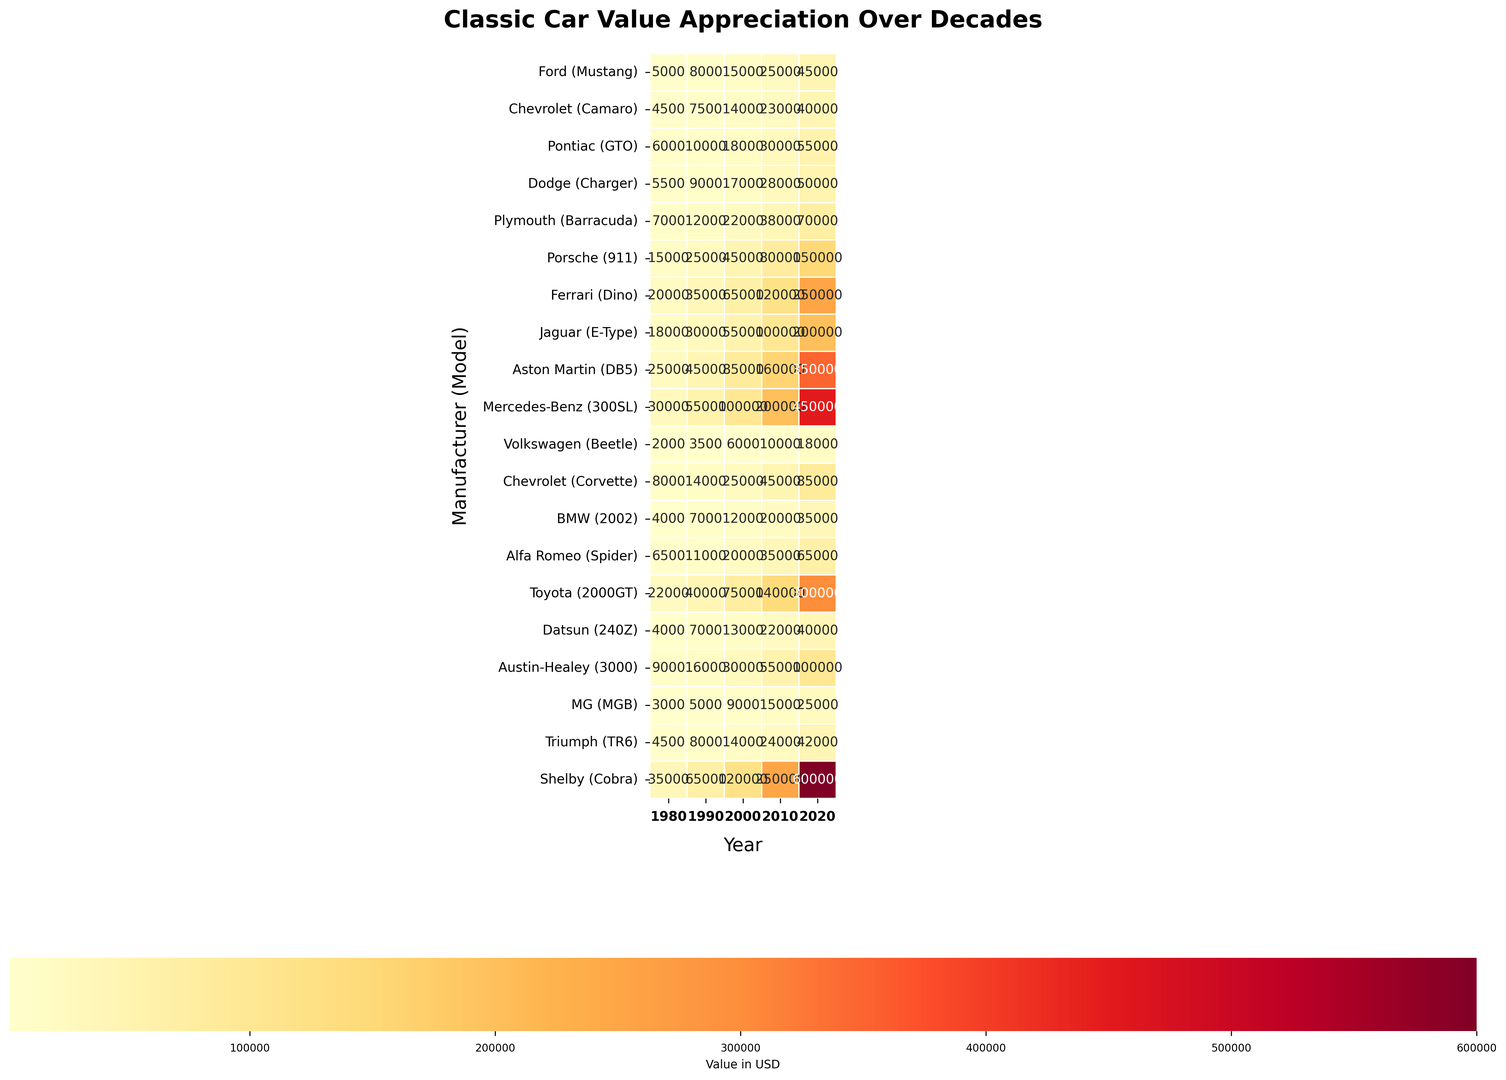Which car model has the highest value in 2020? Look at the 2020 column and identify the car with the highest value. The Ferrari Dino has a value of 250000, Jaguar E-Type has a value of 200000, Aston Martin DB5 has a value of 350000, Mercedes-Benz 300SL has a value of 450000, and Shelby Cobra has a value of 600000. Hence, the Shelby Cobra has the highest value in 2020.
Answer: Shelby Cobra Which car had the greatest appreciation in value from 1980 to 2020? Calculate the difference between the 1980 and 2020 values for each model. The Shelby Cobra increased from 35000 to 600000, which is an increase of 565000, the highest among all models.
Answer: Shelby Cobra Compare the value of the Porsche 911 and the Chevrolet Camaro in 2000. Examine the 2000 column and note the values for Porsche 911 and Chevrolet Camaro. Porsche 911 was valued at 45000, while Chevrolet Camaro was valued at 14000. So, Porsche 911 had a significantly higher value.
Answer: Porsche 911 Which cars have values exceeding $100,000 in 2010? Look at the 2010 column and identify all values greater than 100000. Aston Martin DB5 (160000), Mercedes-Benz 300SL (200000), Ferrari Dino (120000), and Toyota 2000GT (140000) exceed this value.
Answer: Aston Martin DB5, Mercedes-Benz 300SL, Ferrari Dino, Toyota 2000GT Was the value appreciation of the Ford Mustang steady over the decades? By looking at the values across the years for Ford Mustang: 5000 in 1980, 8000 in 1990, 15000 in 2000, 25000 in 2010, and 45000 in 2020, we see a consistent increase in value over the decades.
Answer: Yes Does the Volkswagen Beetle ever reach a value of $20000? Check the values for Volkswagen Beetle across all years, noting the peak value of 18000 in 2020, which does not reach 20000.
Answer: No What is the difference in the 1980 values between the highest and lowest valued cars? Note the highest and lowest values in 1980. The highest value is for Mercedes-Benz 300SL at 30000, and the lowest is for Volkswagen Beetle at 2000. The difference is 30000 - 2000 = 28000.
Answer: 28000 Which car's value doubled from 1990 to 2000? Compare the values for all cars between 1990 and 2000. BMW 2002's value increased from 7000 in 1990 to 12000 in 2000, which is not a double. The Volkswagen Beetle increased from 3500 in 1990 to 6000 in 2000, which also isn’t a double. The Ford Mustang's value increased from 8000 to 15000, approximately but not precisely a double. No values between two specific years double exactly.
Answer: None Is there any manufacturer whose all models appreciated in value from 1980 to 2020? Look at the differences in values from 1980 to 2020 for each model and manufacturer to see if all have appreciated. All listed models across manufacturers show an increase.
Answer: Yes Which model shows the most value appreciation from 2000 to 2010 among the American cars? For American models (Ford Mustang, Chevrolet Camaro, Pontiac GTO, Dodge Charger, Plymouth Barracuda, Chevrolet Corvette, Shelby Cobra), check the differences from 2000 to 2010. Shelby Cobra shows an increase from 120000 to 250000, the highest appreciation.
Answer: Shelby Cobra 